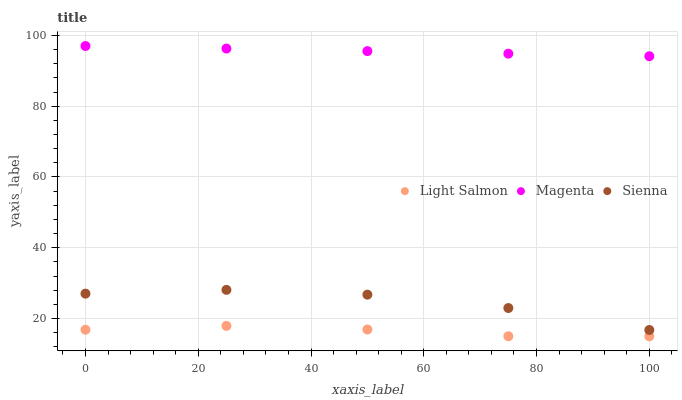Does Light Salmon have the minimum area under the curve?
Answer yes or no. Yes. Does Magenta have the maximum area under the curve?
Answer yes or no. Yes. Does Magenta have the minimum area under the curve?
Answer yes or no. No. Does Light Salmon have the maximum area under the curve?
Answer yes or no. No. Is Magenta the smoothest?
Answer yes or no. Yes. Is Sienna the roughest?
Answer yes or no. Yes. Is Light Salmon the smoothest?
Answer yes or no. No. Is Light Salmon the roughest?
Answer yes or no. No. Does Light Salmon have the lowest value?
Answer yes or no. Yes. Does Magenta have the lowest value?
Answer yes or no. No. Does Magenta have the highest value?
Answer yes or no. Yes. Does Light Salmon have the highest value?
Answer yes or no. No. Is Sienna less than Magenta?
Answer yes or no. Yes. Is Sienna greater than Light Salmon?
Answer yes or no. Yes. Does Sienna intersect Magenta?
Answer yes or no. No. 